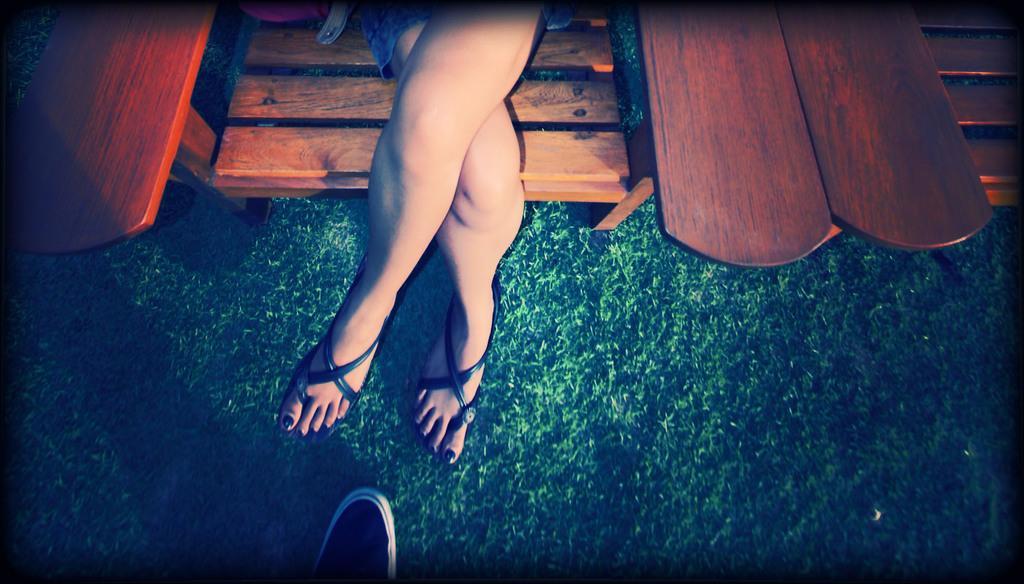Please provide a concise description of this image. In the picture we can see a woman's leg, she is sitting in the chair and beside her we can see another chair on the grass surface and the front of her we can see a shoe on the surface. 